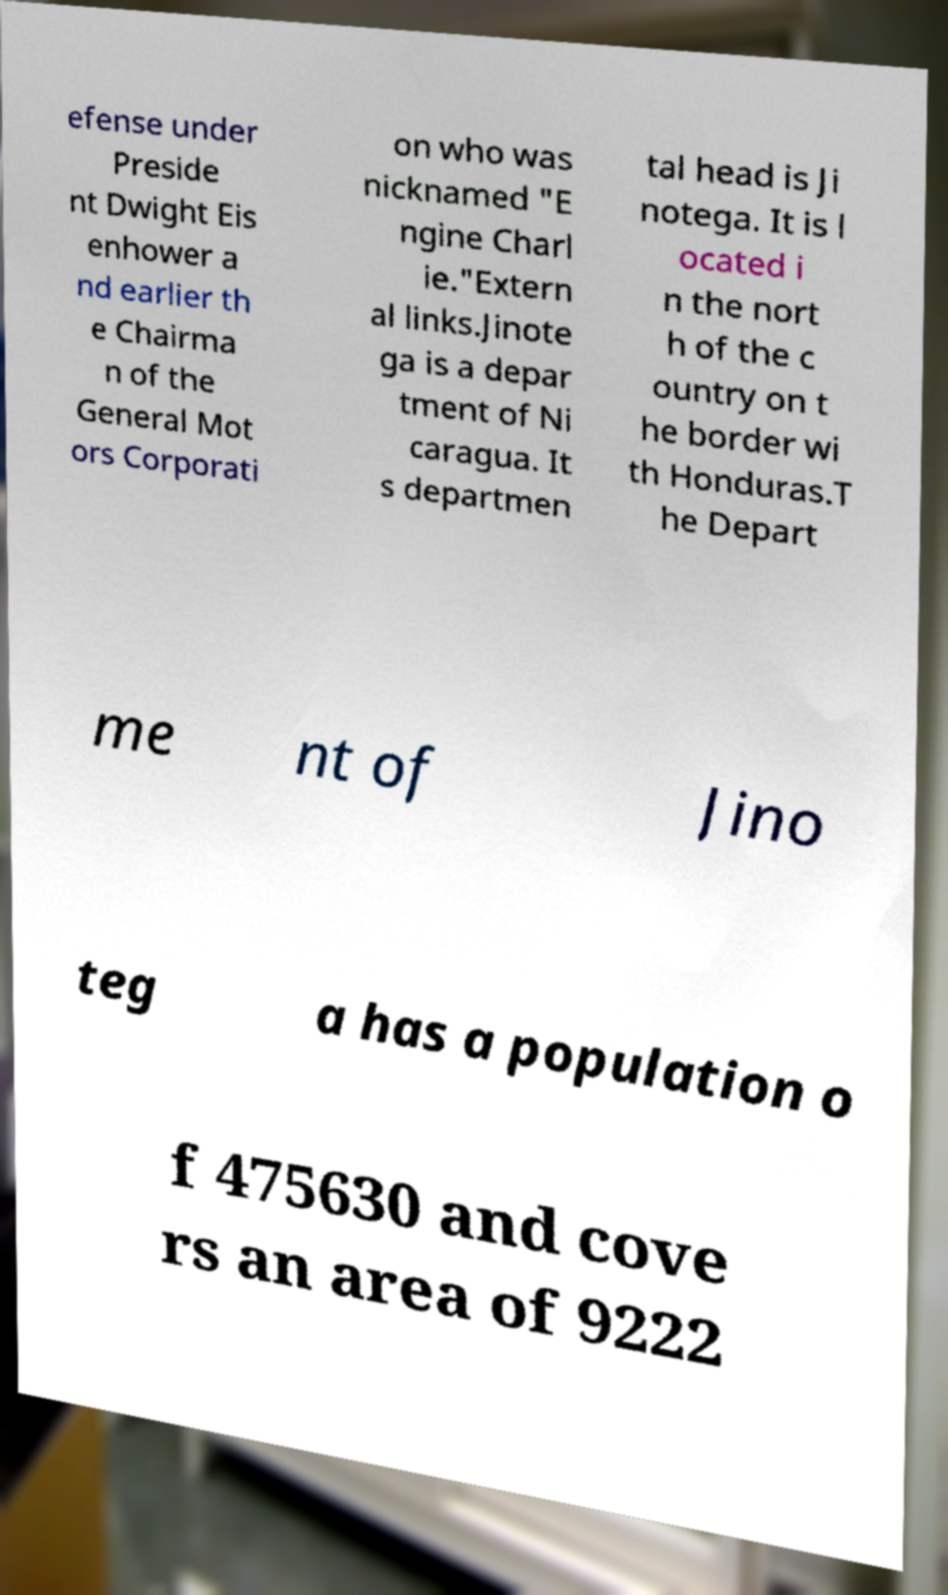I need the written content from this picture converted into text. Can you do that? efense under Preside nt Dwight Eis enhower a nd earlier th e Chairma n of the General Mot ors Corporati on who was nicknamed "E ngine Charl ie."Extern al links.Jinote ga is a depar tment of Ni caragua. It s departmen tal head is Ji notega. It is l ocated i n the nort h of the c ountry on t he border wi th Honduras.T he Depart me nt of Jino teg a has a population o f 475630 and cove rs an area of 9222 